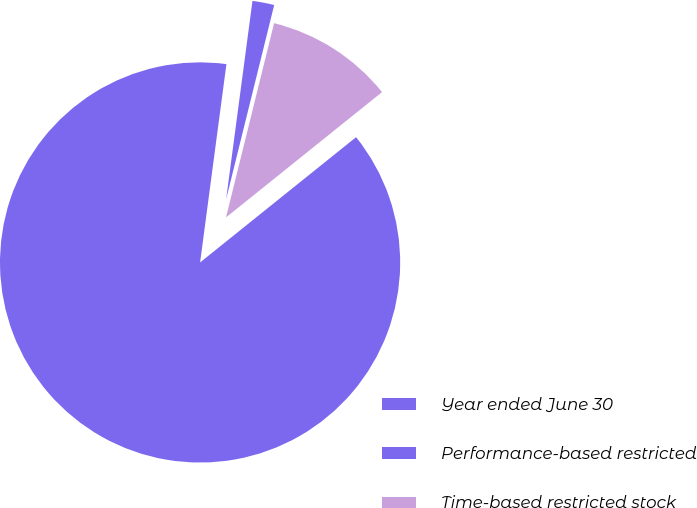Convert chart. <chart><loc_0><loc_0><loc_500><loc_500><pie_chart><fcel>Year ended June 30<fcel>Performance-based restricted<fcel>Time-based restricted stock<nl><fcel>87.87%<fcel>1.76%<fcel>10.37%<nl></chart> 